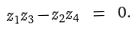<formula> <loc_0><loc_0><loc_500><loc_500>z _ { 1 } z _ { 3 } - z _ { 2 } z _ { 4 } \ = \ 0 .</formula> 